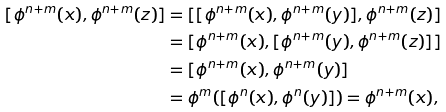Convert formula to latex. <formula><loc_0><loc_0><loc_500><loc_500>[ \phi ^ { n + m } ( x ) , \phi ^ { n + m } ( z ) ] & = [ [ \phi ^ { n + m } ( x ) , \phi ^ { n + m } ( y ) ] , \phi ^ { n + m } ( z ) ] \\ & = [ \phi ^ { n + m } ( x ) , [ \phi ^ { n + m } ( y ) , \phi ^ { n + m } ( z ) ] ] \\ & = [ \phi ^ { n + m } ( x ) , \phi ^ { n + m } ( y ) ] \\ & = \phi ^ { m } ( [ \phi ^ { n } ( x ) , \phi ^ { n } ( y ) ] ) = \phi ^ { n + m } ( x ) ,</formula> 